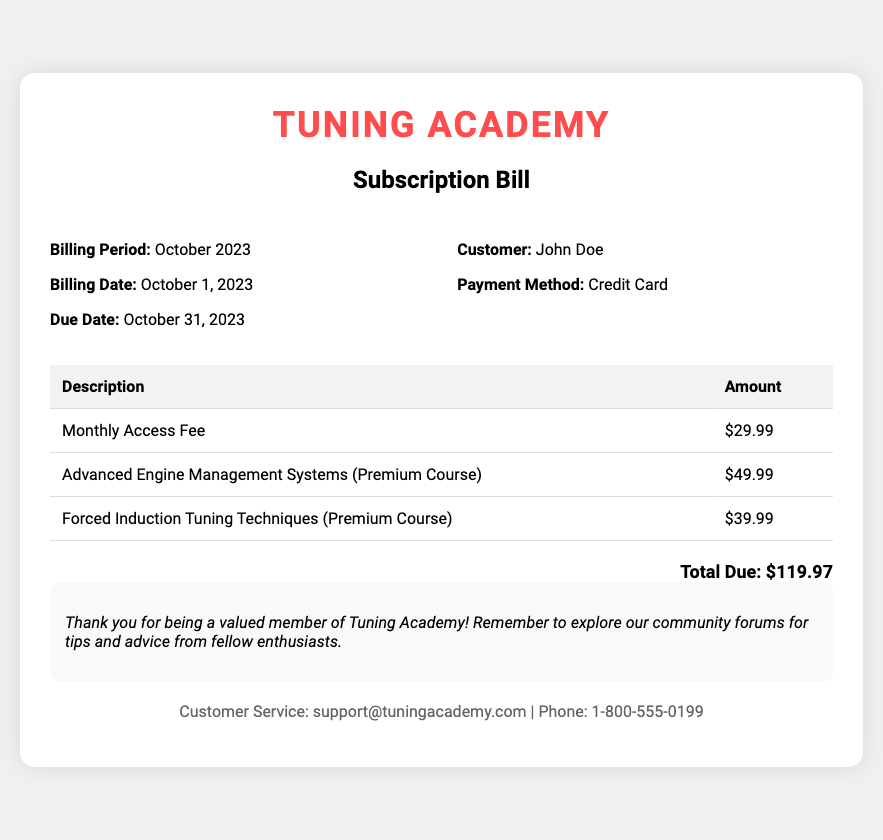what is the billing period? The billing period is specified in the document, indicating the timeframe for which the bill is applicable.
Answer: October 2023 what is the total amount due? The total amount due is provided in the document, calculated as the sum of all charges listed.
Answer: $119.97 when is the due date? The due date is mentioned in the document, indicating when the payment should be made.
Answer: October 31, 2023 who is the customer? The document specifies the name of the customer being billed.
Answer: John Doe how much is the Monthly Access Fee? The Monthly Access Fee is listed separately in the document.
Answer: $29.99 how many premium courses are listed? The document contains a section detailing premium courses, allowing for a count of those available.
Answer: 2 what payment method was used? The payment method Section indicates how the payment was processed for this subscription.
Answer: Credit Card what is the title of the first premium course? The title of the first premium course is listed in the document, providing insight into what is offered.
Answer: Advanced Engine Management Systems what kind of additional charges does this bill include? The bill lists various charges and specifies the category of additional services.
Answer: Premium Courses 